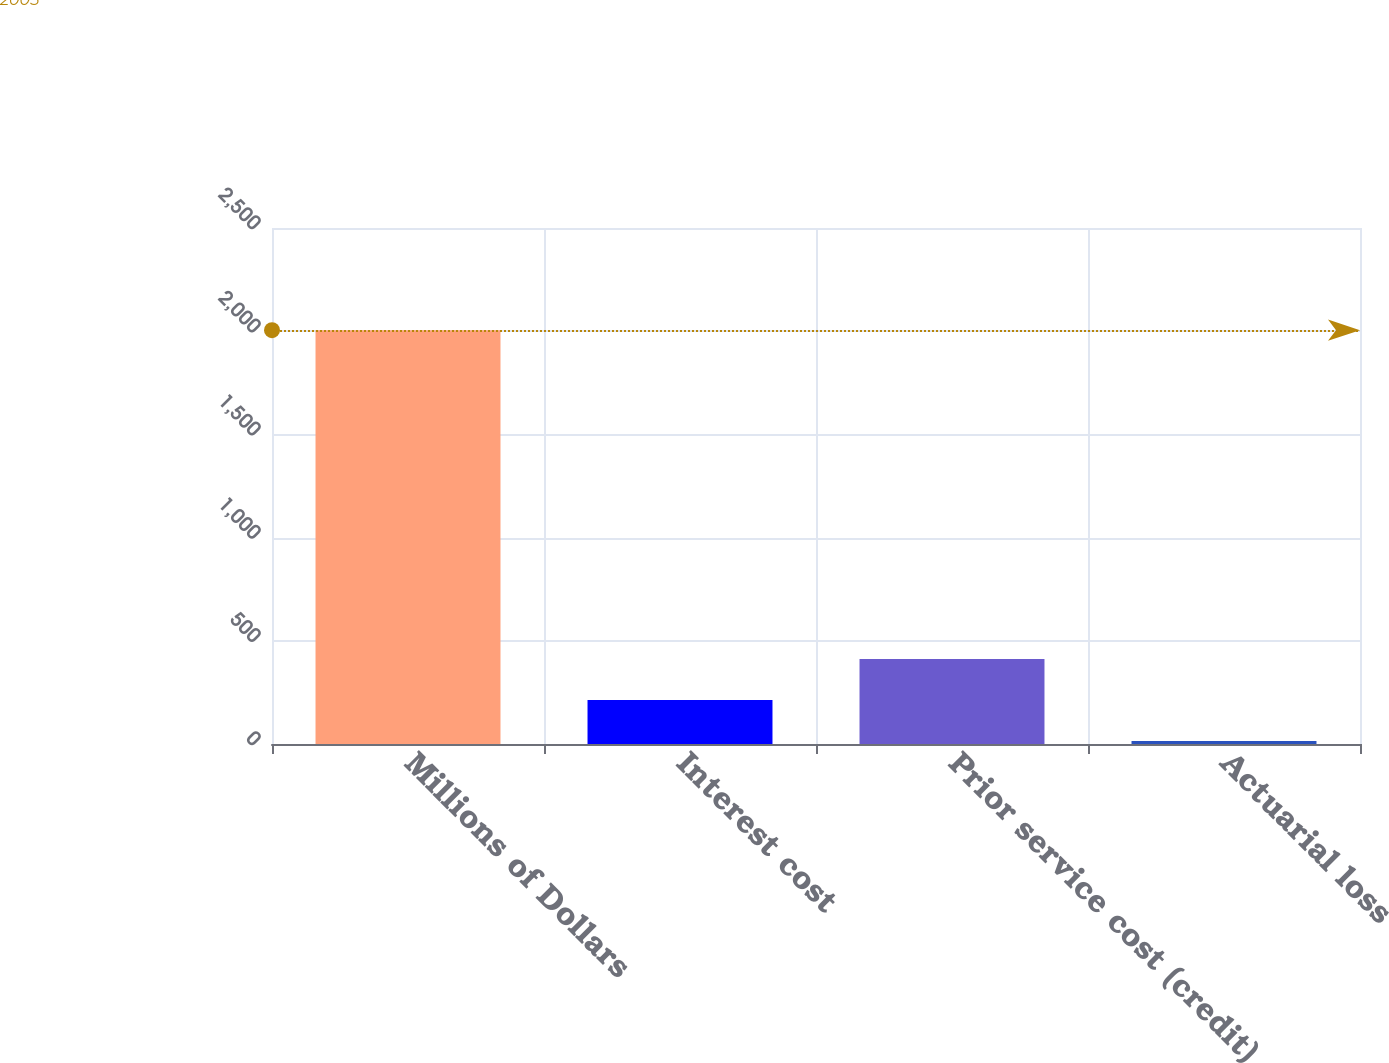<chart> <loc_0><loc_0><loc_500><loc_500><bar_chart><fcel>Millions of Dollars<fcel>Interest cost<fcel>Prior service cost (credit)<fcel>Actuarial loss<nl><fcel>2005<fcel>213.1<fcel>412.2<fcel>14<nl></chart> 